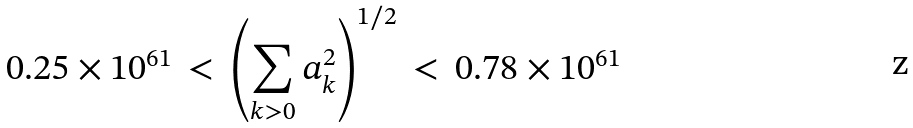<formula> <loc_0><loc_0><loc_500><loc_500>0 . 2 5 \times 1 0 ^ { 6 1 } \, < \, \left ( \sum _ { k > 0 } a _ { k } ^ { 2 } \right ) ^ { 1 / 2 } \, < \, 0 . 7 8 \times 1 0 ^ { 6 1 }</formula> 